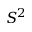Convert formula to latex. <formula><loc_0><loc_0><loc_500><loc_500>S ^ { 2 }</formula> 